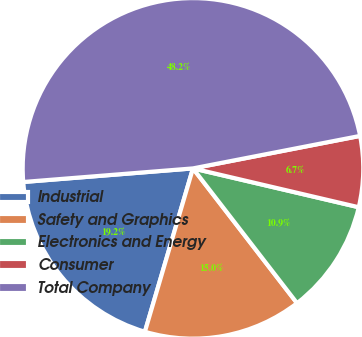Convert chart. <chart><loc_0><loc_0><loc_500><loc_500><pie_chart><fcel>Industrial<fcel>Safety and Graphics<fcel>Electronics and Energy<fcel>Consumer<fcel>Total Company<nl><fcel>19.17%<fcel>15.02%<fcel>10.87%<fcel>6.72%<fcel>48.21%<nl></chart> 